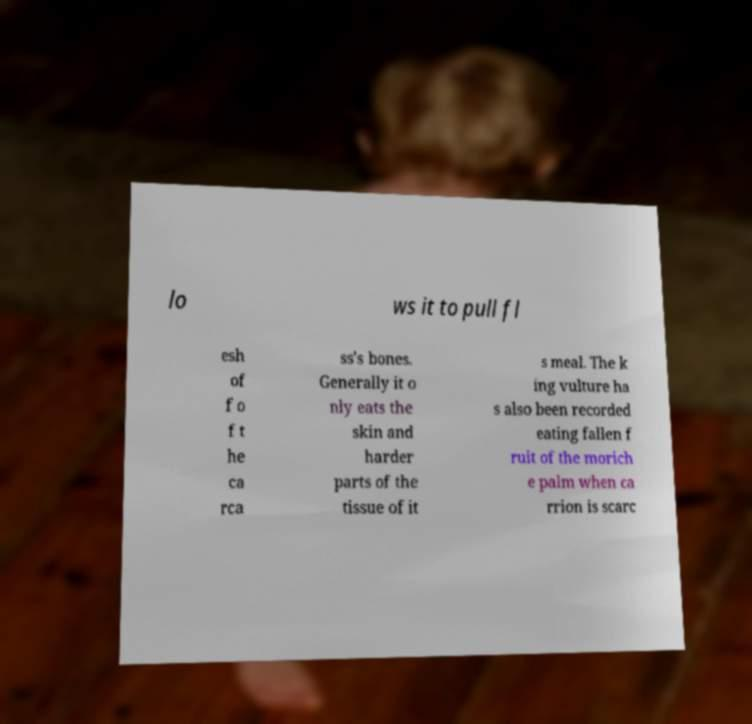I need the written content from this picture converted into text. Can you do that? lo ws it to pull fl esh of f o f t he ca rca ss's bones. Generally it o nly eats the skin and harder parts of the tissue of it s meal. The k ing vulture ha s also been recorded eating fallen f ruit of the morich e palm when ca rrion is scarc 